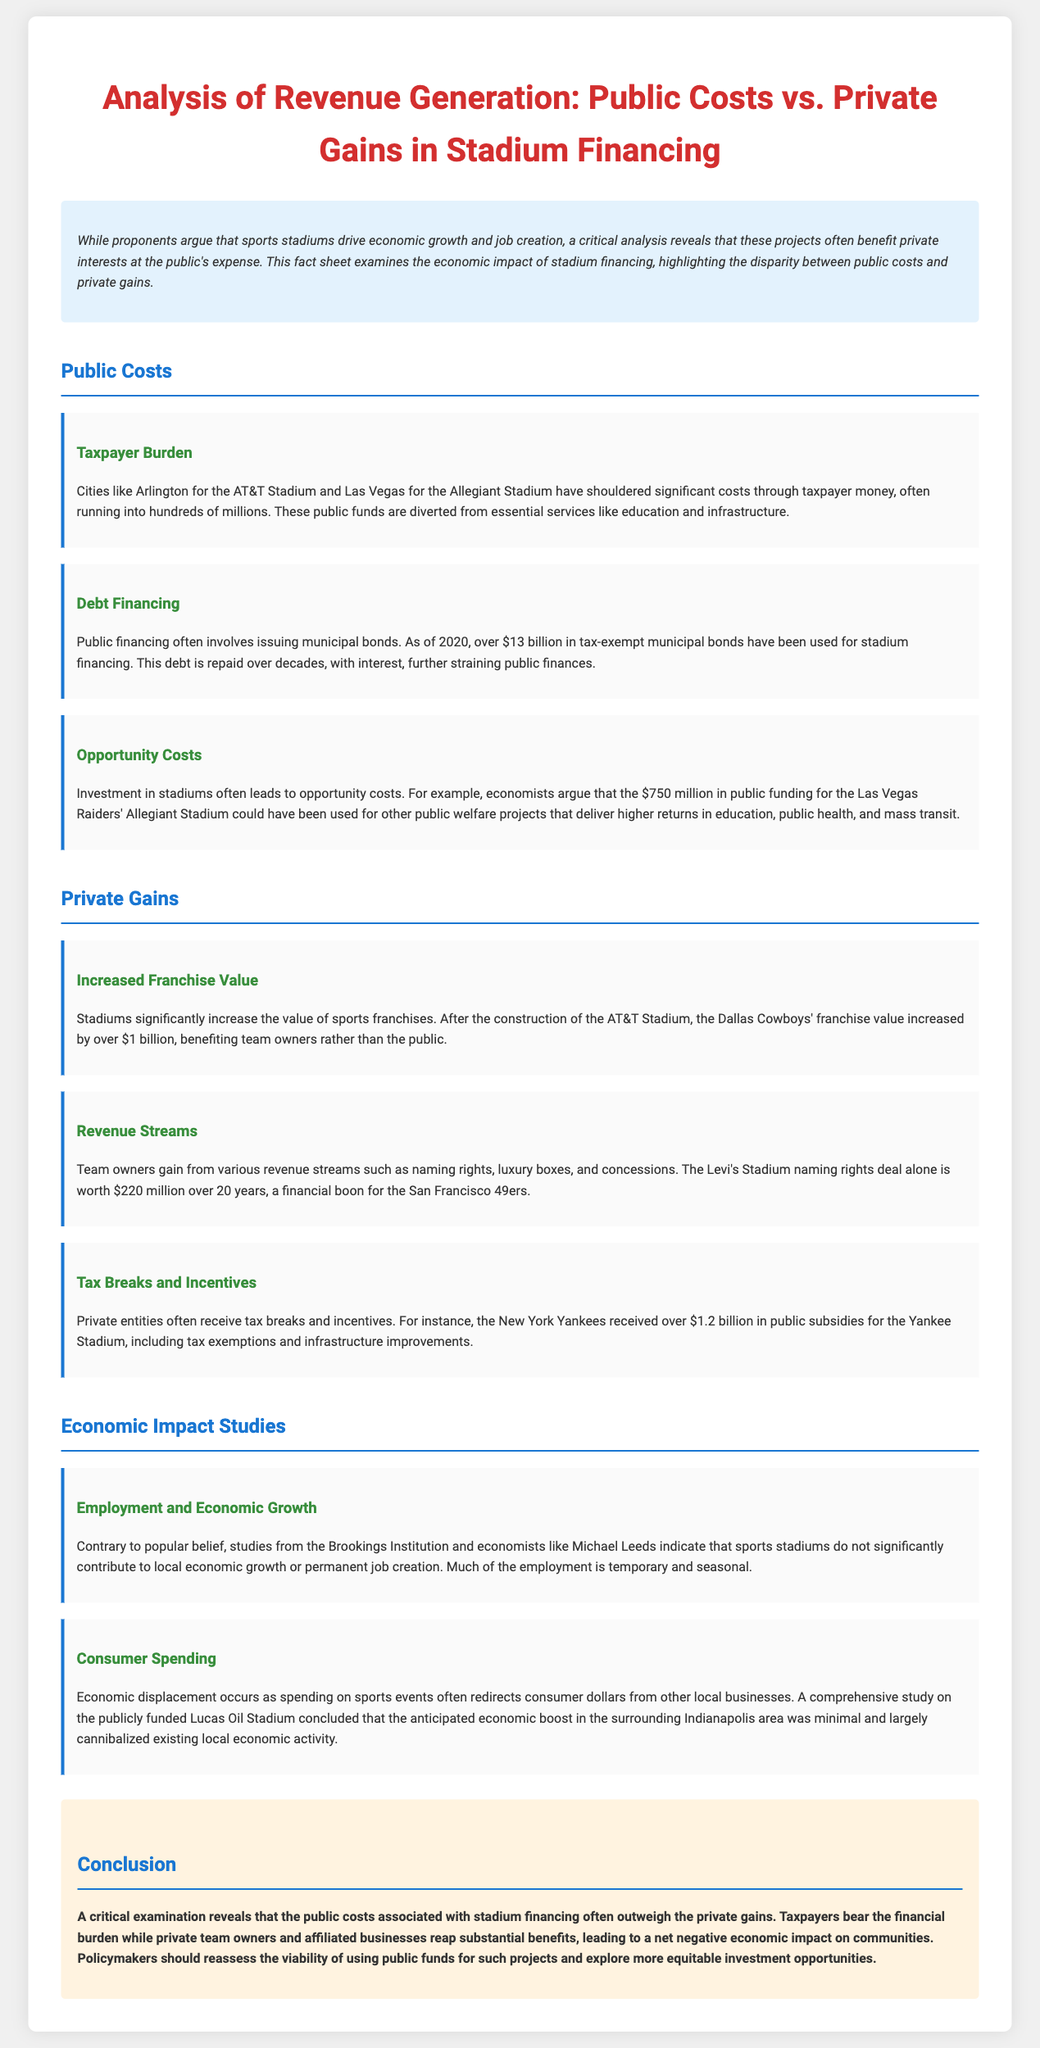what is the public funding for the Allegiant Stadium? The document states that economists argue that the $750 million in public funding for the Las Vegas Raiders' Allegiant Stadium could have been used for other public welfare projects.
Answer: $750 million how much in tax-exempt municipal bonds have been used for stadium financing? The document mentions that as of 2020, over $13 billion in tax-exempt municipal bonds have been used for stadium financing.
Answer: over $13 billion what did the Dallas Cowboys' franchise value increase by after AT&T Stadium construction? According to the document, the Dallas Cowboys' franchise value increased by over $1 billion after the construction of the AT&T Stadium.
Answer: over $1 billion how much public subsidies did the New York Yankees receive for their stadium? The document states that the New York Yankees received over $1.2 billion in public subsidies for the Yankee Stadium.
Answer: over $1.2 billion what is a significant finding from studies regarding employment and economic growth? The document states that studies from the Brookings Institution and economists indicate that sports stadiums do not significantly contribute to local economic growth or permanent job creation.
Answer: do not significantly contribute what is one potential outcome of consumer spending due to sports events? The document describes that economic displacement occurs as spending on sports events often redirects consumer dollars from other local businesses.
Answer: economic displacement what is the conclusion about public costs and private gains in stadium financing? The document concludes that public costs associated with stadium financing often outweigh the private gains.
Answer: outweigh the private gains what should policymakers explore according to the conclusion? The conclusion suggests that policymakers should explore more equitable investment opportunities.
Answer: more equitable investment opportunities 